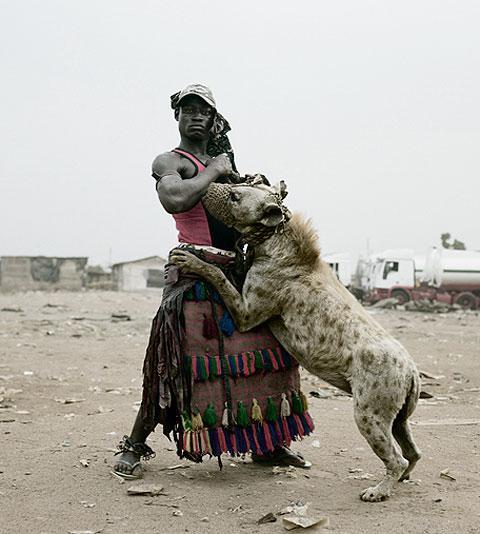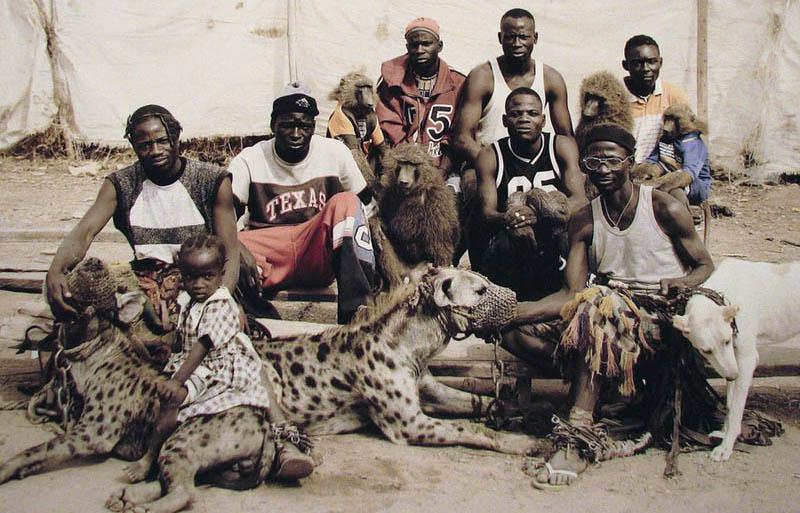The first image is the image on the left, the second image is the image on the right. Evaluate the accuracy of this statement regarding the images: "An image shows a man standing with a hyena that is on all fours.". Is it true? Answer yes or no. No. The first image is the image on the left, the second image is the image on the right. Evaluate the accuracy of this statement regarding the images: "There are at least two people in the image on the right.". Is it true? Answer yes or no. Yes. 